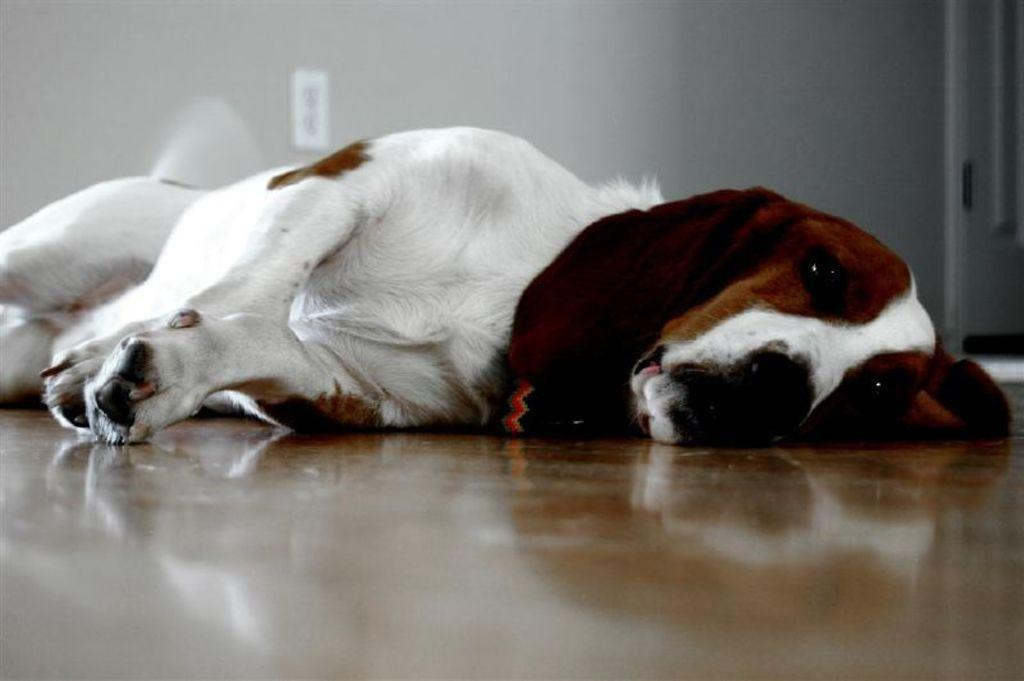What type of animal is present in the image? There is a dog in the image. What is the dog doing in the image? The dog is laying on a surface. What can be seen in the background of the image? There is a wall, a switchboard, and a door in the background of the image. What type of yam is being processed in the image? There is no yam or any indication of a process in the image; it features a dog laying on a surface with a wall, switchboard, and door in the background. 